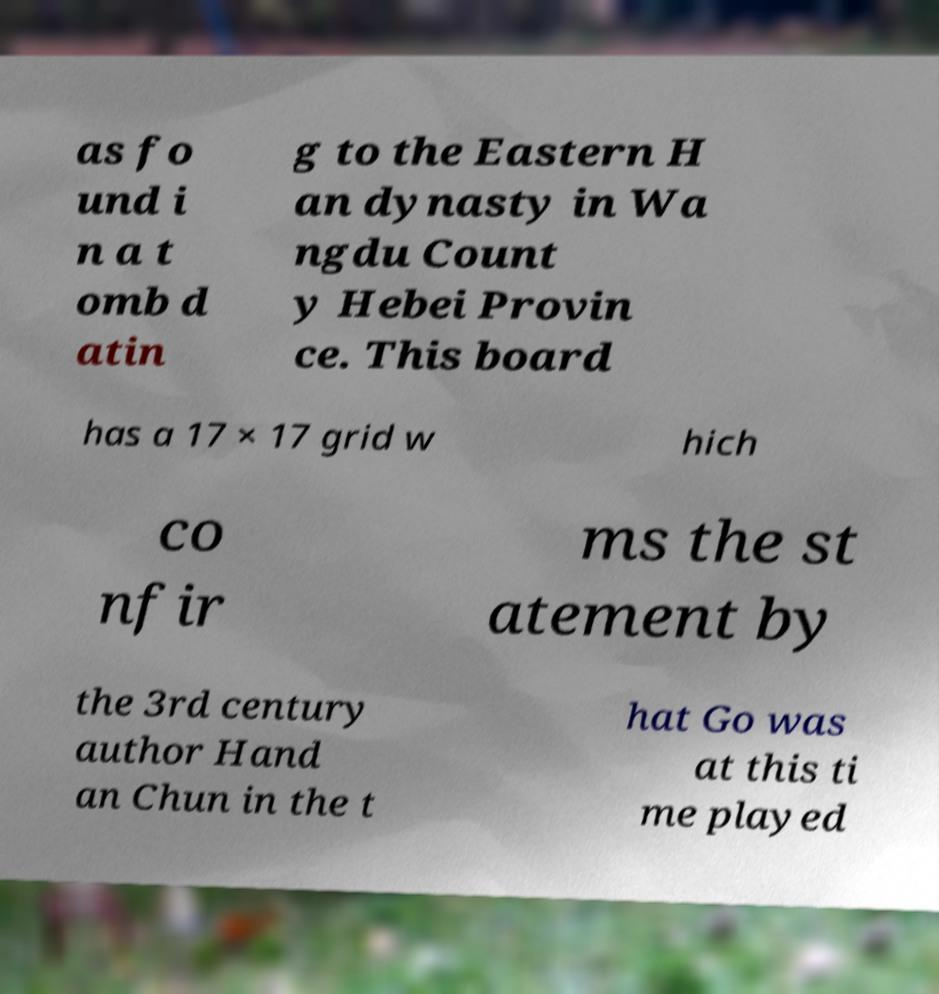There's text embedded in this image that I need extracted. Can you transcribe it verbatim? as fo und i n a t omb d atin g to the Eastern H an dynasty in Wa ngdu Count y Hebei Provin ce. This board has a 17 × 17 grid w hich co nfir ms the st atement by the 3rd century author Hand an Chun in the t hat Go was at this ti me played 